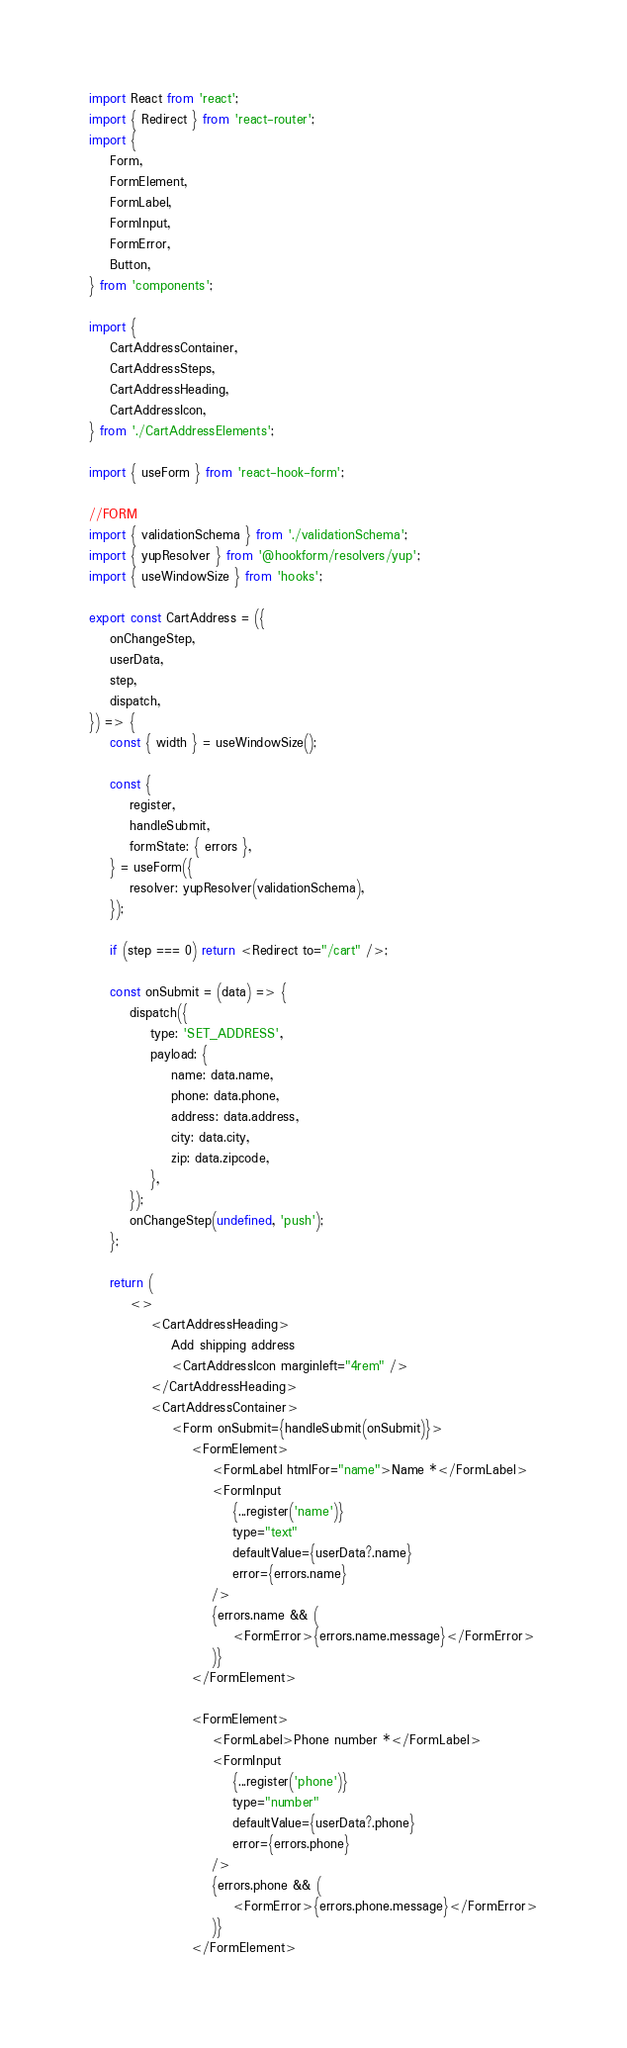Convert code to text. <code><loc_0><loc_0><loc_500><loc_500><_JavaScript_>import React from 'react';
import { Redirect } from 'react-router';
import {
	Form,
	FormElement,
	FormLabel,
	FormInput,
	FormError,
	Button,
} from 'components';

import {
	CartAddressContainer,
	CartAddressSteps,
	CartAddressHeading,
	CartAddressIcon,
} from './CartAddressElements';

import { useForm } from 'react-hook-form';

//FORM
import { validationSchema } from './validationSchema';
import { yupResolver } from '@hookform/resolvers/yup';
import { useWindowSize } from 'hooks';

export const CartAddress = ({
	onChangeStep,
	userData,
	step,
	dispatch,
}) => {
	const { width } = useWindowSize();

	const {
		register,
		handleSubmit,
		formState: { errors },
	} = useForm({
		resolver: yupResolver(validationSchema),
	});

	if (step === 0) return <Redirect to="/cart" />;

	const onSubmit = (data) => {
		dispatch({
			type: 'SET_ADDRESS',
			payload: {
				name: data.name,
				phone: data.phone,
				address: data.address,
				city: data.city,
				zip: data.zipcode,
			},
		});
		onChangeStep(undefined, 'push');
	};

	return (
		<>
			<CartAddressHeading>
				Add shipping address
				<CartAddressIcon marginleft="4rem" />
			</CartAddressHeading>
			<CartAddressContainer>
				<Form onSubmit={handleSubmit(onSubmit)}>
					<FormElement>
						<FormLabel htmlFor="name">Name *</FormLabel>
						<FormInput
							{...register('name')}
							type="text"
							defaultValue={userData?.name}
							error={errors.name}
						/>
						{errors.name && (
							<FormError>{errors.name.message}</FormError>
						)}
					</FormElement>

					<FormElement>
						<FormLabel>Phone number *</FormLabel>
						<FormInput
							{...register('phone')}
							type="number"
							defaultValue={userData?.phone}
							error={errors.phone}
						/>
						{errors.phone && (
							<FormError>{errors.phone.message}</FormError>
						)}
					</FormElement>
</code> 